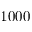<formula> <loc_0><loc_0><loc_500><loc_500>1 0 0 0</formula> 